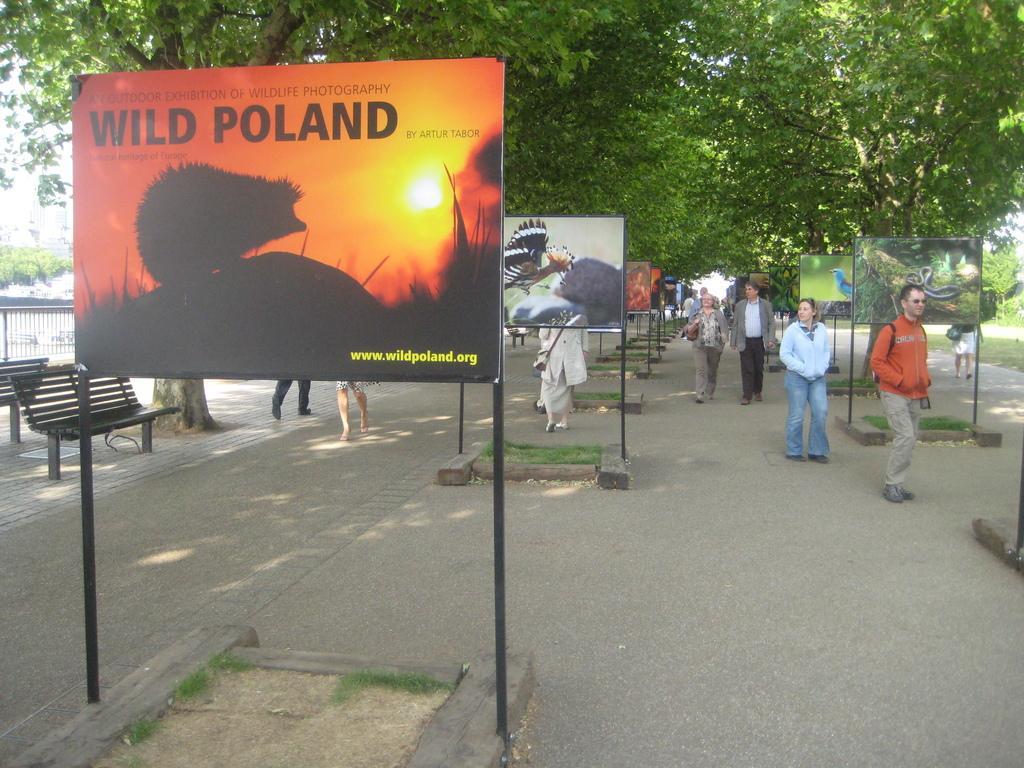Could you give a brief overview of what you see in this image? There are advertising boards are present on the road as we can see in the middle of this image. There are some persons in the background. There is a table on the left side of this image and there is a road at the bottom of this image. There are some trees at the top of this image. 